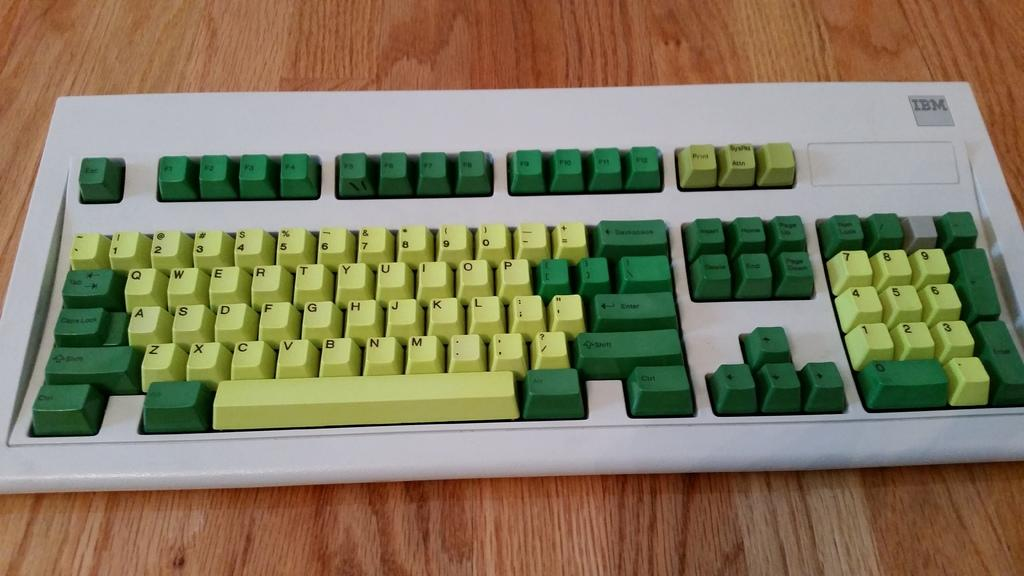<image>
Provide a brief description of the given image. the label IBM is on the keyboard that is green 